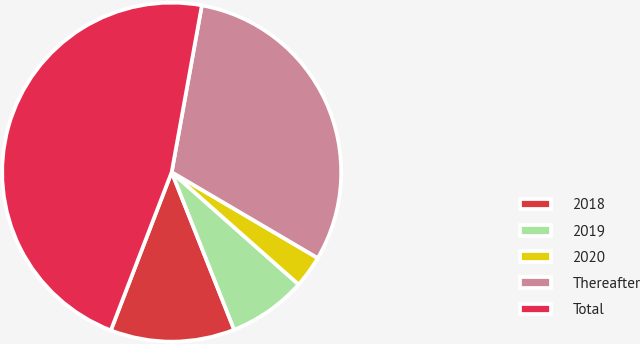Convert chart. <chart><loc_0><loc_0><loc_500><loc_500><pie_chart><fcel>2018<fcel>2019<fcel>2020<fcel>Thereafter<fcel>Total<nl><fcel>11.85%<fcel>7.46%<fcel>3.07%<fcel>30.61%<fcel>47.0%<nl></chart> 